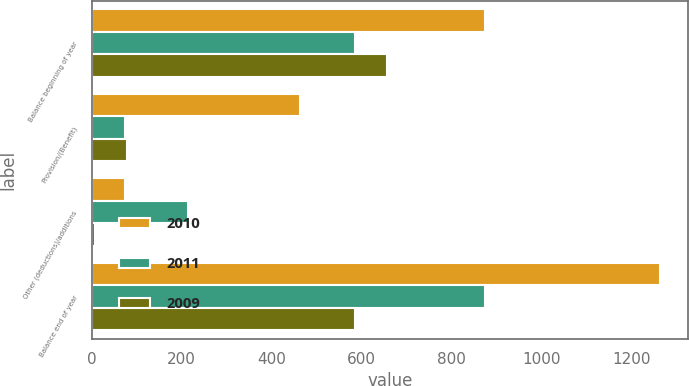<chart> <loc_0><loc_0><loc_500><loc_500><stacked_bar_chart><ecel><fcel>Balance beginning of year<fcel>Provision/(Benefit)<fcel>Other (deductions)/additions<fcel>Balance end of year<nl><fcel>2010<fcel>875<fcel>464<fcel>75<fcel>1264<nl><fcel>2011<fcel>586<fcel>75<fcel>214<fcel>875<nl><fcel>2009<fcel>657<fcel>78<fcel>7<fcel>586<nl></chart> 